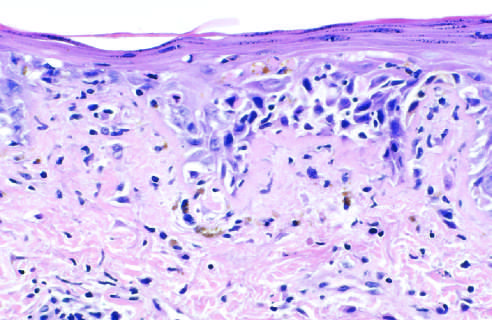what does an h&e-stained section show of the basal layer of the epidermis and edema at the dermoepidermal junction?
Answer the question using a single word or phrase. Liquefactive degeneration 